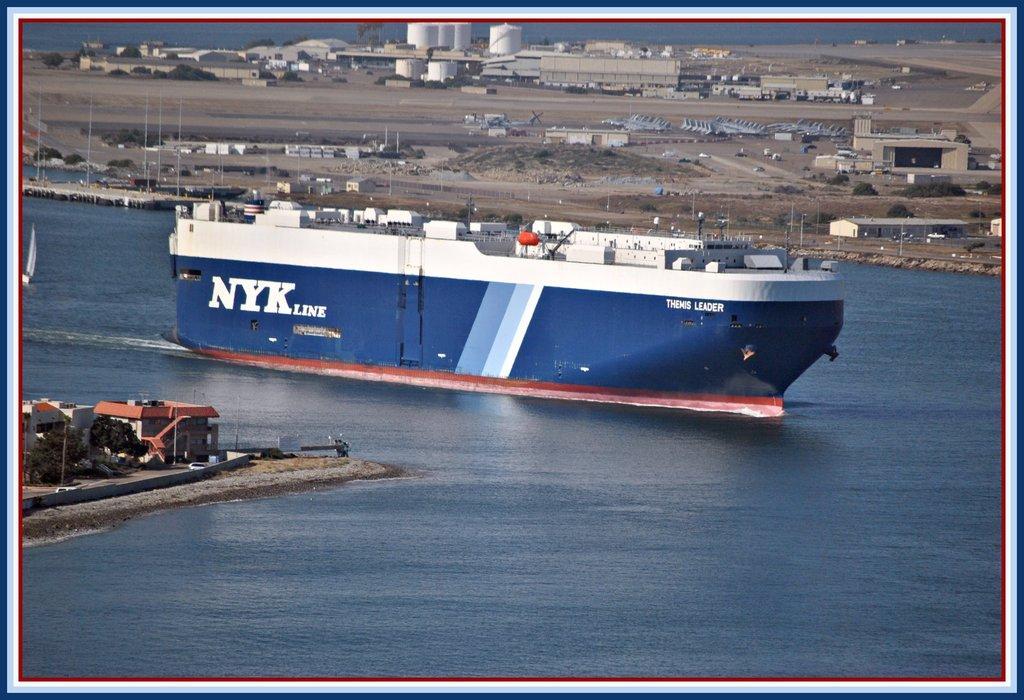Could you give a brief overview of what you see in this image? This is an edited image. In the middle of the image there is a ship on the water. On the left side there are few buildings, trees and also I can see few vehicles on the road. In the background there are many buildings on the ground. 